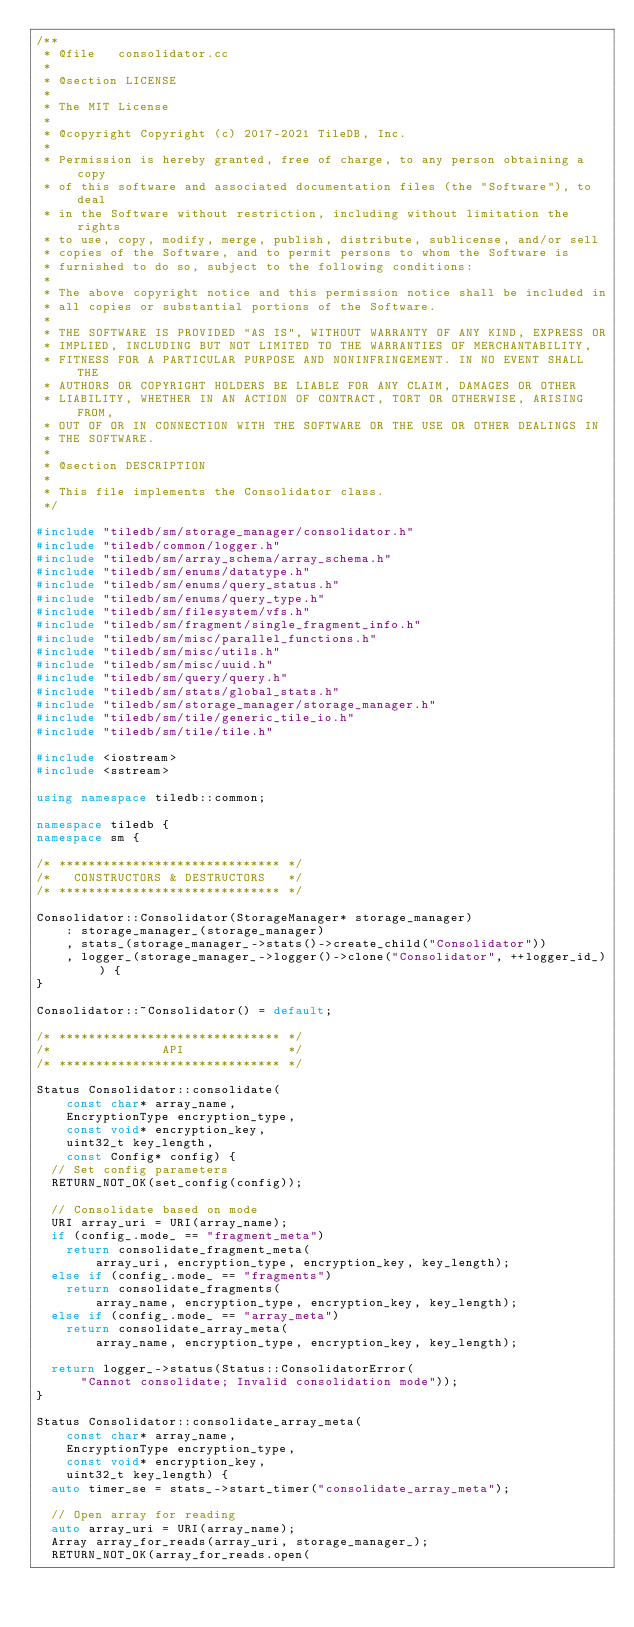Convert code to text. <code><loc_0><loc_0><loc_500><loc_500><_C++_>/**
 * @file   consolidator.cc
 *
 * @section LICENSE
 *
 * The MIT License
 *
 * @copyright Copyright (c) 2017-2021 TileDB, Inc.
 *
 * Permission is hereby granted, free of charge, to any person obtaining a copy
 * of this software and associated documentation files (the "Software"), to deal
 * in the Software without restriction, including without limitation the rights
 * to use, copy, modify, merge, publish, distribute, sublicense, and/or sell
 * copies of the Software, and to permit persons to whom the Software is
 * furnished to do so, subject to the following conditions:
 *
 * The above copyright notice and this permission notice shall be included in
 * all copies or substantial portions of the Software.
 *
 * THE SOFTWARE IS PROVIDED "AS IS", WITHOUT WARRANTY OF ANY KIND, EXPRESS OR
 * IMPLIED, INCLUDING BUT NOT LIMITED TO THE WARRANTIES OF MERCHANTABILITY,
 * FITNESS FOR A PARTICULAR PURPOSE AND NONINFRINGEMENT. IN NO EVENT SHALL THE
 * AUTHORS OR COPYRIGHT HOLDERS BE LIABLE FOR ANY CLAIM, DAMAGES OR OTHER
 * LIABILITY, WHETHER IN AN ACTION OF CONTRACT, TORT OR OTHERWISE, ARISING FROM,
 * OUT OF OR IN CONNECTION WITH THE SOFTWARE OR THE USE OR OTHER DEALINGS IN
 * THE SOFTWARE.
 *
 * @section DESCRIPTION
 *
 * This file implements the Consolidator class.
 */

#include "tiledb/sm/storage_manager/consolidator.h"
#include "tiledb/common/logger.h"
#include "tiledb/sm/array_schema/array_schema.h"
#include "tiledb/sm/enums/datatype.h"
#include "tiledb/sm/enums/query_status.h"
#include "tiledb/sm/enums/query_type.h"
#include "tiledb/sm/filesystem/vfs.h"
#include "tiledb/sm/fragment/single_fragment_info.h"
#include "tiledb/sm/misc/parallel_functions.h"
#include "tiledb/sm/misc/utils.h"
#include "tiledb/sm/misc/uuid.h"
#include "tiledb/sm/query/query.h"
#include "tiledb/sm/stats/global_stats.h"
#include "tiledb/sm/storage_manager/storage_manager.h"
#include "tiledb/sm/tile/generic_tile_io.h"
#include "tiledb/sm/tile/tile.h"

#include <iostream>
#include <sstream>

using namespace tiledb::common;

namespace tiledb {
namespace sm {

/* ****************************** */
/*   CONSTRUCTORS & DESTRUCTORS   */
/* ****************************** */

Consolidator::Consolidator(StorageManager* storage_manager)
    : storage_manager_(storage_manager)
    , stats_(storage_manager_->stats()->create_child("Consolidator"))
    , logger_(storage_manager_->logger()->clone("Consolidator", ++logger_id_)) {
}

Consolidator::~Consolidator() = default;

/* ****************************** */
/*               API              */
/* ****************************** */

Status Consolidator::consolidate(
    const char* array_name,
    EncryptionType encryption_type,
    const void* encryption_key,
    uint32_t key_length,
    const Config* config) {
  // Set config parameters
  RETURN_NOT_OK(set_config(config));

  // Consolidate based on mode
  URI array_uri = URI(array_name);
  if (config_.mode_ == "fragment_meta")
    return consolidate_fragment_meta(
        array_uri, encryption_type, encryption_key, key_length);
  else if (config_.mode_ == "fragments")
    return consolidate_fragments(
        array_name, encryption_type, encryption_key, key_length);
  else if (config_.mode_ == "array_meta")
    return consolidate_array_meta(
        array_name, encryption_type, encryption_key, key_length);

  return logger_->status(Status::ConsolidatorError(
      "Cannot consolidate; Invalid consolidation mode"));
}

Status Consolidator::consolidate_array_meta(
    const char* array_name,
    EncryptionType encryption_type,
    const void* encryption_key,
    uint32_t key_length) {
  auto timer_se = stats_->start_timer("consolidate_array_meta");

  // Open array for reading
  auto array_uri = URI(array_name);
  Array array_for_reads(array_uri, storage_manager_);
  RETURN_NOT_OK(array_for_reads.open(</code> 